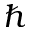<formula> <loc_0><loc_0><loc_500><loc_500>\hbar</formula> 